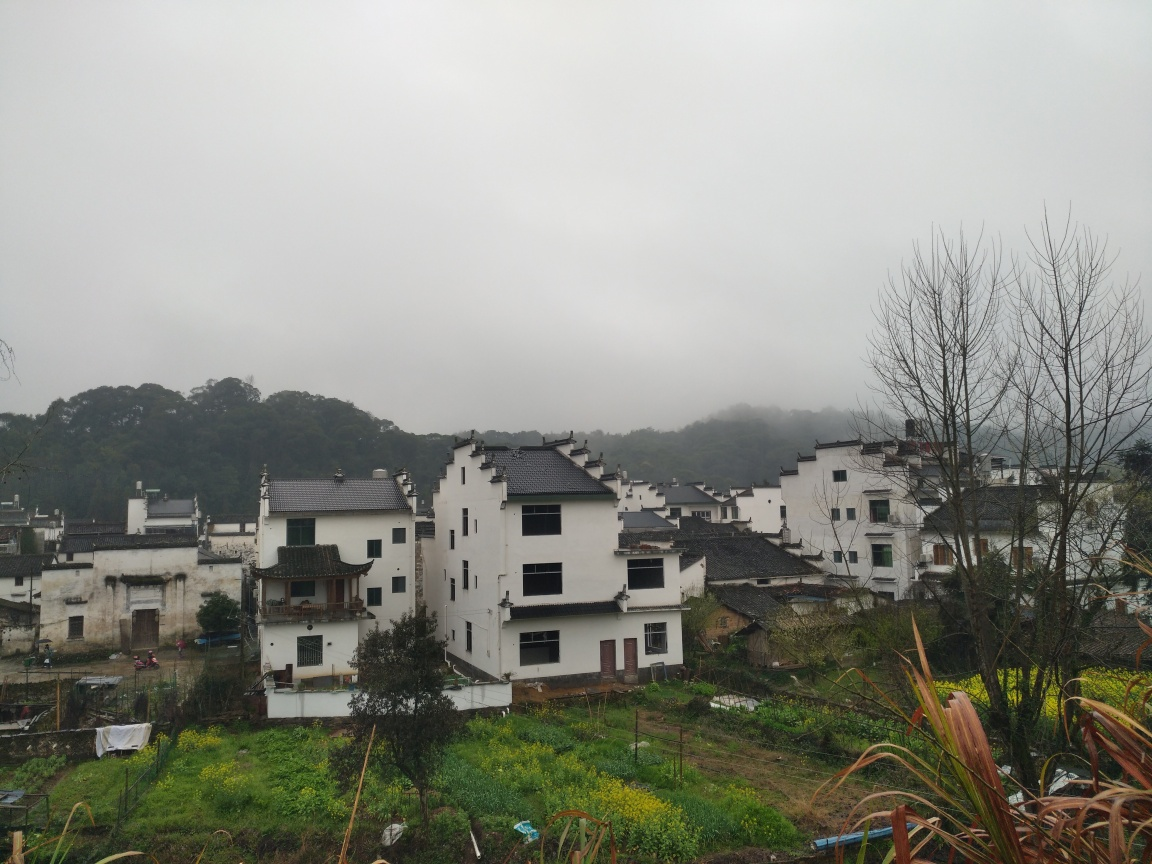How would you describe the quality of this picture?
A. Average
B. Good
C. Excellent
D. Bad The quality of this picture could be described as good (Option B) due to the clear capture of the architectural details and the natural environment. Although the overcast sky results in a somewhat muted color palette, the composition is well-framed, balancing the built houses with the surrounding nature, and there is sufficient resolution to make out individual elements of the scene. 